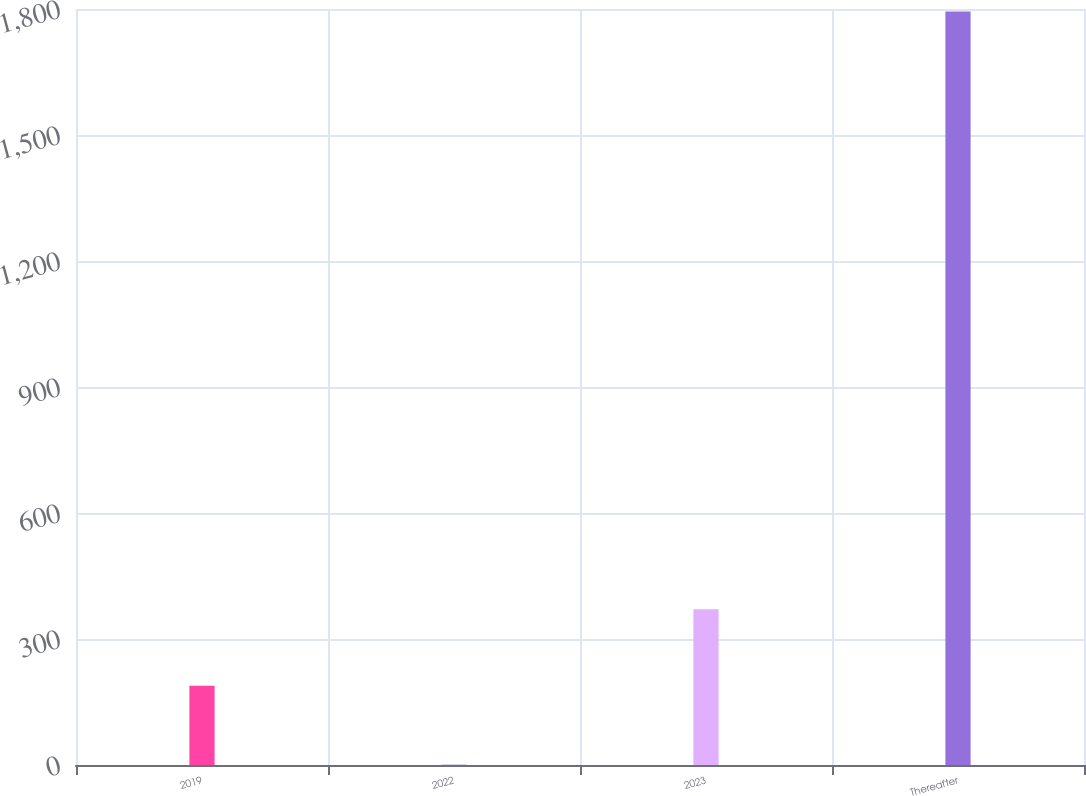<chart> <loc_0><loc_0><loc_500><loc_500><bar_chart><fcel>2019<fcel>2022<fcel>2023<fcel>Thereafter<nl><fcel>188.5<fcel>0.4<fcel>370.8<fcel>1794.3<nl></chart> 